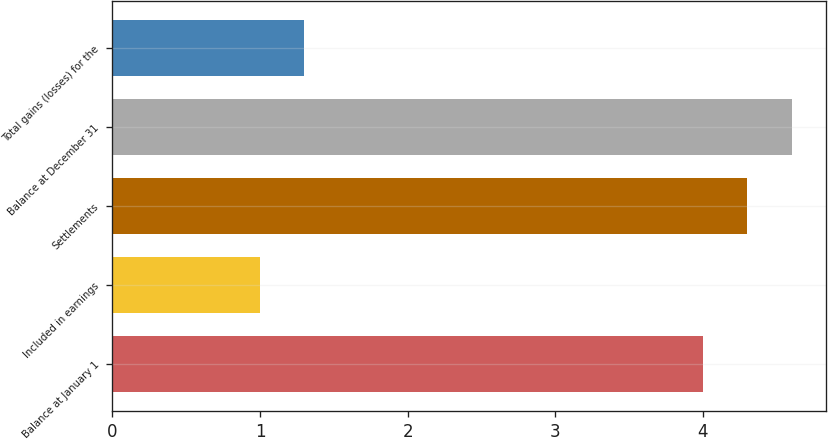Convert chart. <chart><loc_0><loc_0><loc_500><loc_500><bar_chart><fcel>Balance at January 1<fcel>Included in earnings<fcel>Settlements<fcel>Balance at December 31<fcel>Total gains (losses) for the<nl><fcel>4<fcel>1<fcel>4.3<fcel>4.6<fcel>1.3<nl></chart> 